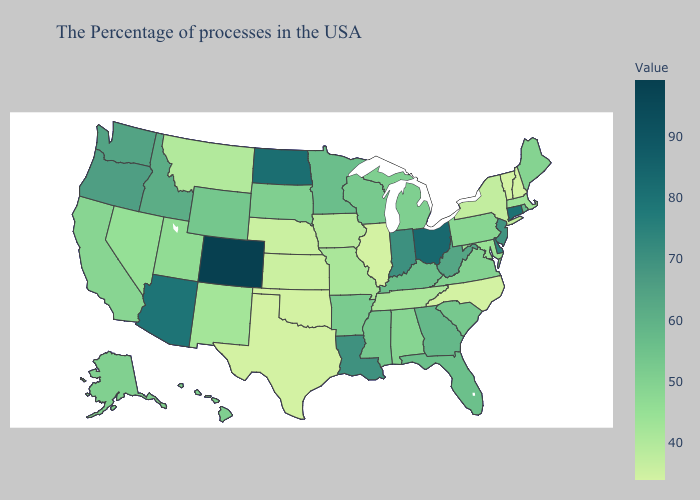Does Mississippi have the lowest value in the South?
Concise answer only. No. Which states hav the highest value in the MidWest?
Write a very short answer. Ohio. Does Washington have the lowest value in the West?
Concise answer only. No. Among the states that border Idaho , does Montana have the lowest value?
Keep it brief. Yes. 